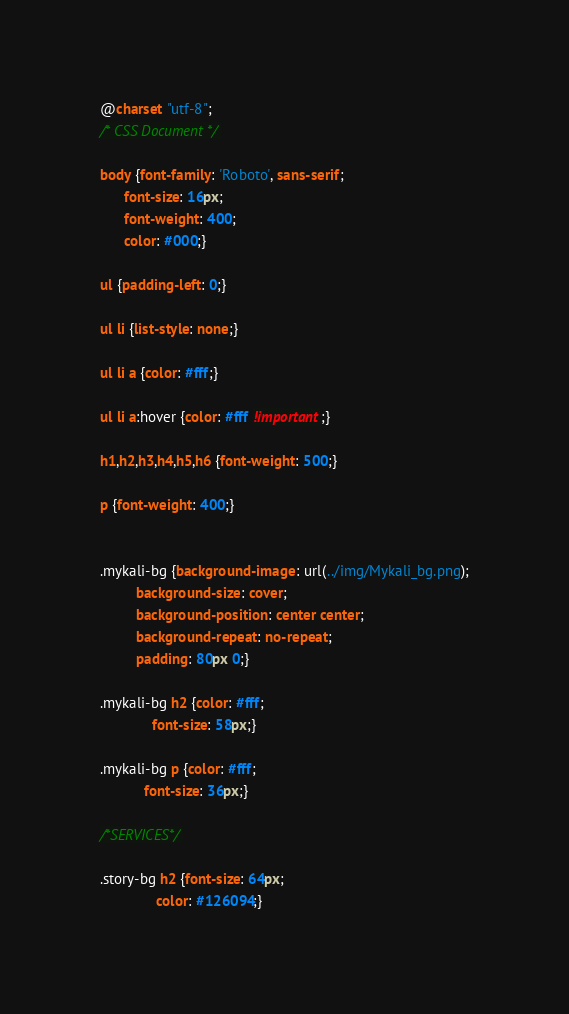Convert code to text. <code><loc_0><loc_0><loc_500><loc_500><_CSS_>@charset "utf-8";
/* CSS Document */

body {font-family: 'Roboto', sans-serif;
      font-size: 16px;
      font-weight: 400;
      color: #000;}

ul {padding-left: 0;}

ul li {list-style: none;}

ul li a {color: #fff;}

ul li a:hover {color: #fff !important;}

h1,h2,h3,h4,h5,h6 {font-weight: 500;}

p {font-weight: 400;}


.mykali-bg {background-image: url(../img/Mykali_bg.png);
         background-size: cover;
         background-position: center center;
         background-repeat: no-repeat;
         padding: 80px 0;}

.mykali-bg h2 {color: #fff;
             font-size: 58px;}

.mykali-bg p {color: #fff;
           font-size: 36px;}

/*SERVICES*/

.story-bg h2 {font-size: 64px;
              color: #126094;}
</code> 